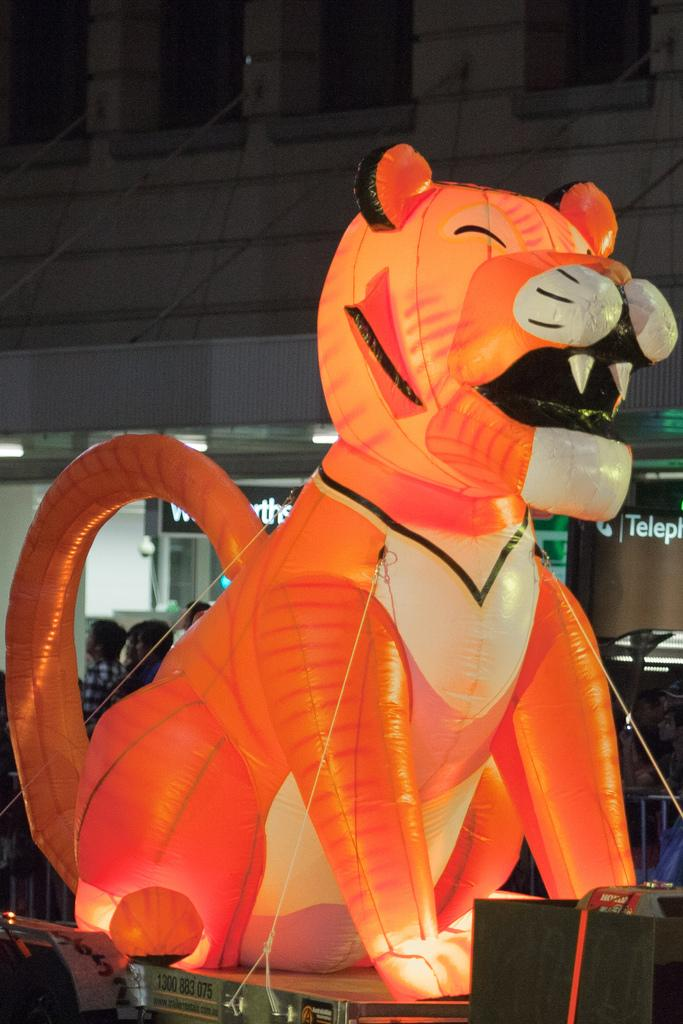What type of object is on the surface in the image? There is a toy animal on the surface in the image. What can be seen in the background of the image? There is a wall visible in the background of the image, and there are people present in the background as well. How many bikes are being used to answer the questions in the image? There are no bikes present in the image, and bikes are not involved in answering questions. 